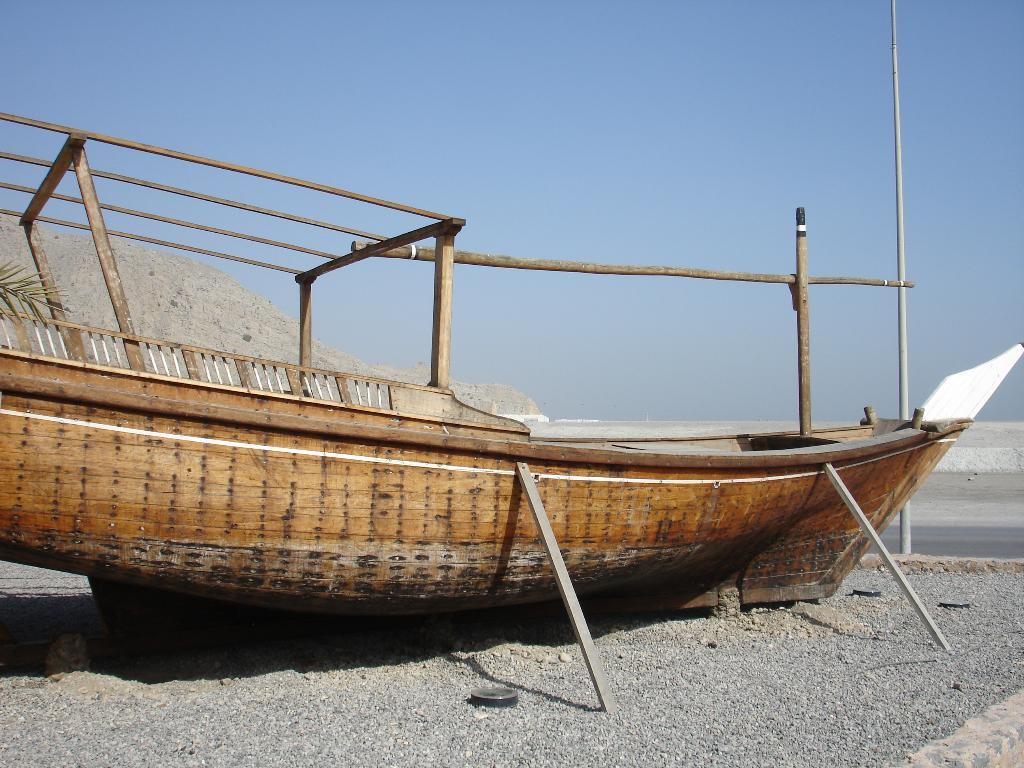What is the main subject in the foreground of the image? There is a boat in the foreground of the image. What is the current position of the boat? The boat is on the ground. What can be seen in the background of the image? There is a pole and the sky visible in the background of the image. What type of vegetation is present on the left side of the image? There is a leaf of a tree or a plant on the left side of the image. What type of plastic material is used to make the boat's nerve in the image? There is no mention of a boat's nerve in the image, and the boat's construction material is not specified. 